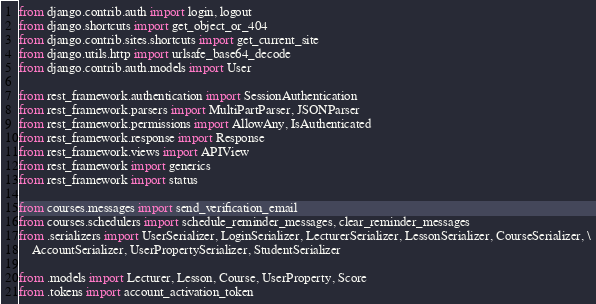<code> <loc_0><loc_0><loc_500><loc_500><_Python_>from django.contrib.auth import login, logout
from django.shortcuts import get_object_or_404
from django.contrib.sites.shortcuts import get_current_site
from django.utils.http import urlsafe_base64_decode
from django.contrib.auth.models import User

from rest_framework.authentication import SessionAuthentication
from rest_framework.parsers import MultiPartParser, JSONParser
from rest_framework.permissions import AllowAny, IsAuthenticated
from rest_framework.response import Response
from rest_framework.views import APIView
from rest_framework import generics
from rest_framework import status

from courses.messages import send_verification_email
from courses.schedulers import schedule_reminder_messages, clear_reminder_messages
from .serializers import UserSerializer, LoginSerializer, LecturerSerializer, LessonSerializer, CourseSerializer, \
    AccountSerializer, UserPropertySerializer, StudentSerializer

from .models import Lecturer, Lesson, Course, UserProperty, Score
from .tokens import account_activation_token

</code> 